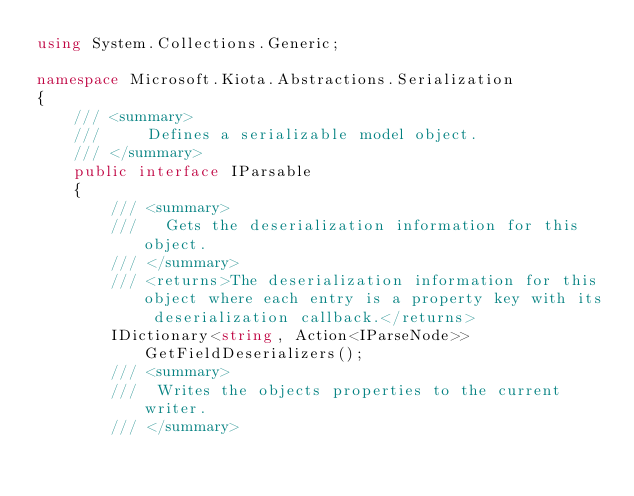<code> <loc_0><loc_0><loc_500><loc_500><_C#_>using System.Collections.Generic;

namespace Microsoft.Kiota.Abstractions.Serialization
{
    /// <summary>
    ///     Defines a serializable model object.
    /// </summary>
    public interface IParsable
    {
        /// <summary>
        ///   Gets the deserialization information for this object.
        /// </summary>
        /// <returns>The deserialization information for this object where each entry is a property key with its deserialization callback.</returns>
        IDictionary<string, Action<IParseNode>> GetFieldDeserializers();
        /// <summary>
        ///  Writes the objects properties to the current writer.
        /// </summary></code> 